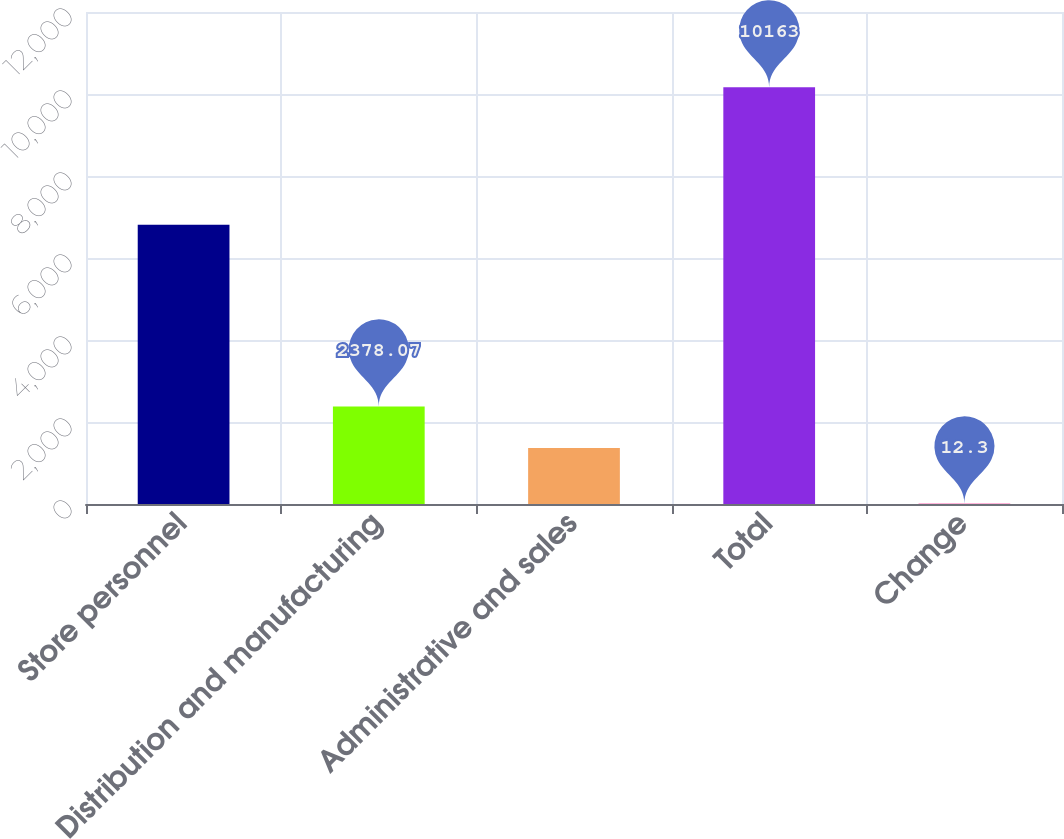Convert chart to OTSL. <chart><loc_0><loc_0><loc_500><loc_500><bar_chart><fcel>Store personnel<fcel>Distribution and manufacturing<fcel>Administrative and sales<fcel>Total<fcel>Change<nl><fcel>6808<fcel>2378.07<fcel>1363<fcel>10163<fcel>12.3<nl></chart> 